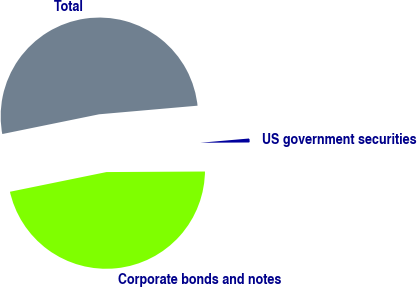Convert chart. <chart><loc_0><loc_0><loc_500><loc_500><pie_chart><fcel>Corporate bonds and notes<fcel>US government securities<fcel>Total<nl><fcel>46.89%<fcel>1.3%<fcel>51.82%<nl></chart> 